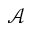Convert formula to latex. <formula><loc_0><loc_0><loc_500><loc_500>\mathcal { A }</formula> 